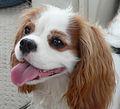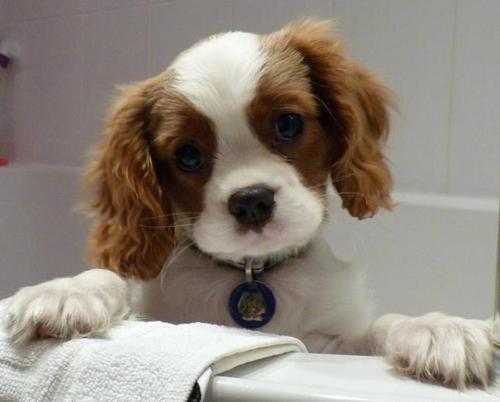The first image is the image on the left, the second image is the image on the right. Given the left and right images, does the statement "There are two dogs looking directly at the camera." hold true? Answer yes or no. No. The first image is the image on the left, the second image is the image on the right. Analyze the images presented: Is the assertion "An image shows a brown and white spaniel puppy on a varnished wood floor." valid? Answer yes or no. No. 